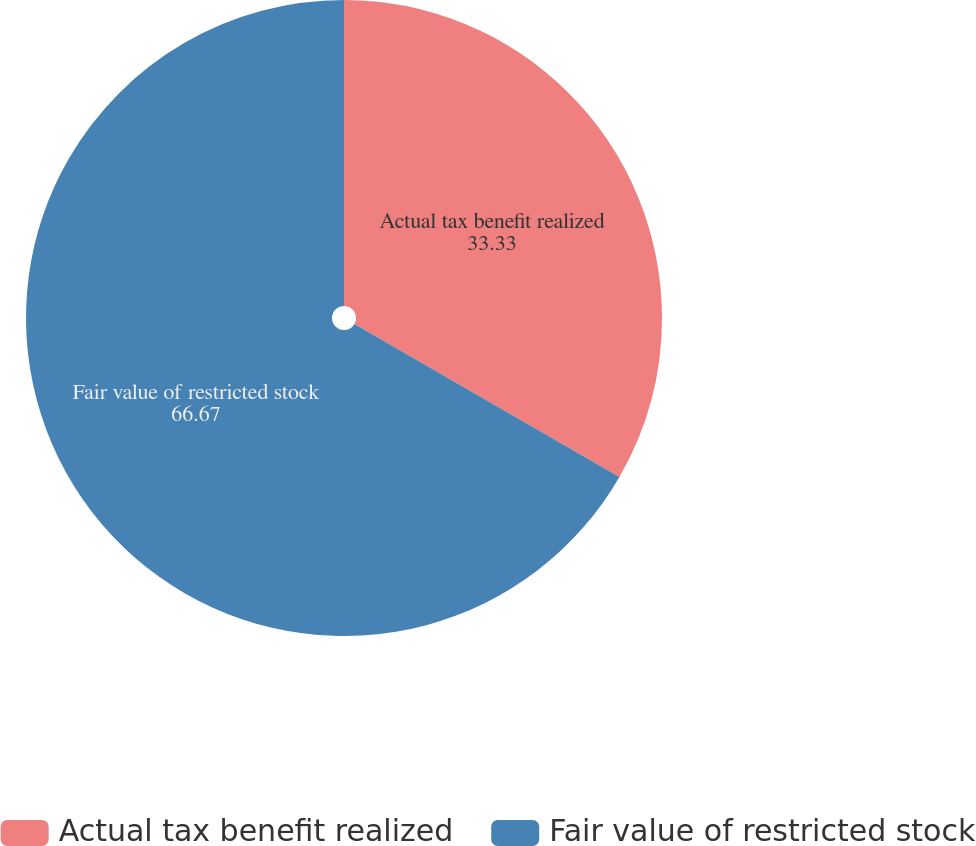Convert chart. <chart><loc_0><loc_0><loc_500><loc_500><pie_chart><fcel>Actual tax benefit realized<fcel>Fair value of restricted stock<nl><fcel>33.33%<fcel>66.67%<nl></chart> 